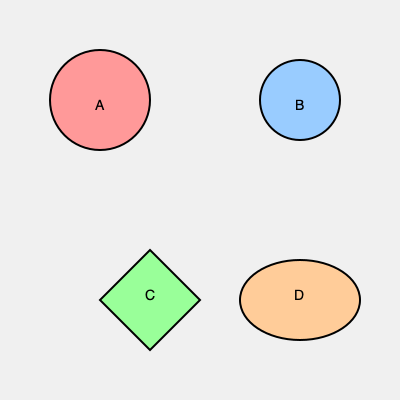Identify the cell types represented in the microscope image of human tissue above. Match the labels A, B, C, and D to the correct cell types: red blood cell, white blood cell, muscle cell, and epithelial cell. To identify the cell types in this microscope image, we need to analyze the characteristics of each labeled cell:

1. Cell A: This cell is large and circular with a pink/red color. These are typical characteristics of a red blood cell (erythrocyte). Red blood cells are biconcave discs, but when viewed under a microscope, they often appear circular.

2. Cell B: This cell is smaller than cell A and has a blue tint. White blood cells (leukocytes) are typically smaller than red blood cells and often appear blue or purple when stained. This matches the characteristics of a white blood cell.

3. Cell C: This cell has an irregular, elongated shape with multiple sides. This is consistent with the appearance of a muscle cell (myocyte). Muscle cells are often polygonal or elongated in shape when viewed in cross-section.

4. Cell D: This cell has an oval or elliptical shape. Epithelial cells, which line various surfaces in the body, often appear flat and scale-like or slightly elongated. The shape of this cell is consistent with an epithelial cell.

Therefore, the correct matching is:
A - Red blood cell
B - White blood cell
C - Muscle cell
D - Epithelial cell
Answer: A: Red blood cell, B: White blood cell, C: Muscle cell, D: Epithelial cell 